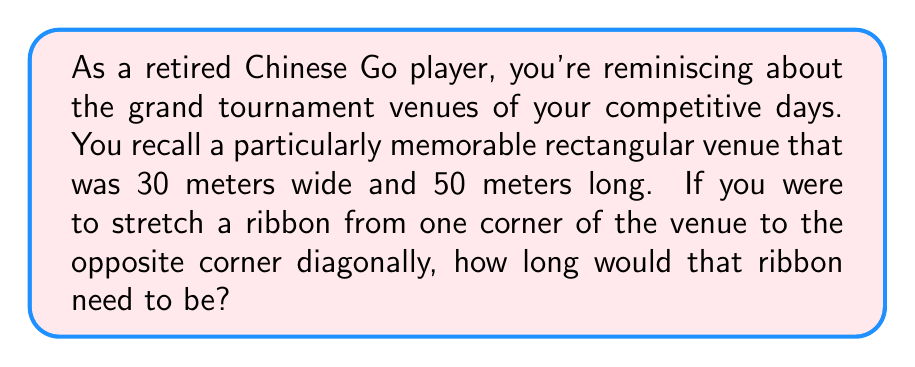Can you solve this math problem? To solve this problem, we need to use the Pythagorean theorem, which states that in a right triangle, the square of the length of the hypotenuse (the diagonal in this case) is equal to the sum of squares of the other two sides.

Let's approach this step-by-step:

1) Let's denote the width of the venue as $w$ and the length as $l$. We're given:
   $w = 30$ meters
   $l = 50$ meters

2) Let's denote the diagonal length as $d$. This is what we need to find.

3) According to the Pythagorean theorem:
   $$d^2 = w^2 + l^2$$

4) Substituting the known values:
   $$d^2 = 30^2 + 50^2$$

5) Simplify:
   $$d^2 = 900 + 2500 = 3400$$

6) To find $d$, we need to take the square root of both sides:
   $$d = \sqrt{3400}$$

7) Simplify the square root:
   $$d = 10\sqrt{34}$$

8) If we want to express this in decimal form:
   $$d \approx 58.31$$

[asy]
import geometry;

pair A=(0,0), B=(30,0), C=(30,50), D=(0,50);
draw(A--B--C--D--cycle);
draw(A--C,dashed);

label("30 m",B,(0,-2));
label("50 m",C+(2,0));
label("$d$",A+(15,25),SE);

[/asy]

The diagonal of the Go tournament venue is $10\sqrt{34}$ meters, or approximately 58.31 meters.
Answer: $10\sqrt{34}$ meters (or approximately 58.31 meters) 